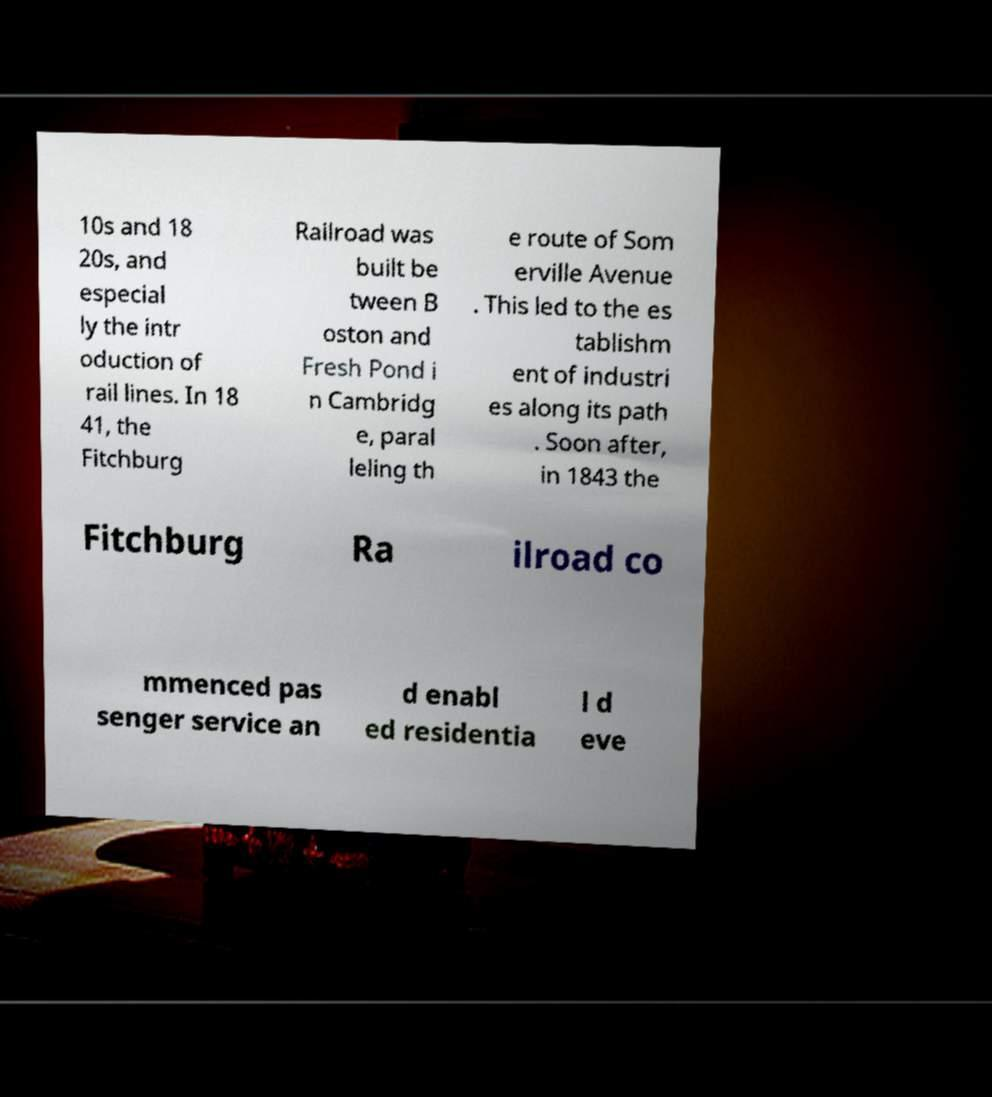Can you accurately transcribe the text from the provided image for me? 10s and 18 20s, and especial ly the intr oduction of rail lines. In 18 41, the Fitchburg Railroad was built be tween B oston and Fresh Pond i n Cambridg e, paral leling th e route of Som erville Avenue . This led to the es tablishm ent of industri es along its path . Soon after, in 1843 the Fitchburg Ra ilroad co mmenced pas senger service an d enabl ed residentia l d eve 